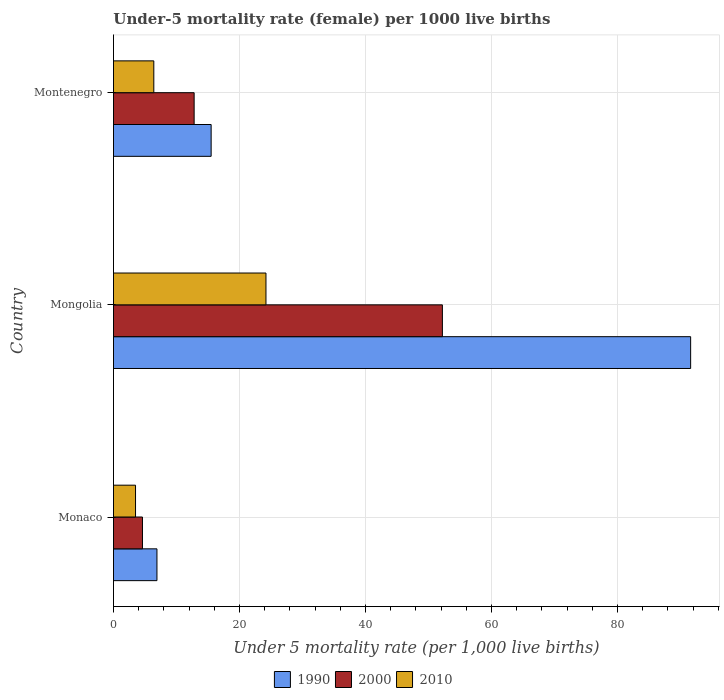How many groups of bars are there?
Provide a succinct answer. 3. What is the label of the 2nd group of bars from the top?
Provide a succinct answer. Mongolia. Across all countries, what is the maximum under-five mortality rate in 2010?
Your answer should be compact. 24.2. Across all countries, what is the minimum under-five mortality rate in 1990?
Your response must be concise. 6.9. In which country was the under-five mortality rate in 2010 maximum?
Provide a succinct answer. Mongolia. In which country was the under-five mortality rate in 1990 minimum?
Give a very brief answer. Monaco. What is the total under-five mortality rate in 2010 in the graph?
Make the answer very short. 34.1. What is the difference between the under-five mortality rate in 2000 in Monaco and that in Montenegro?
Give a very brief answer. -8.2. What is the difference between the under-five mortality rate in 2000 in Mongolia and the under-five mortality rate in 2010 in Montenegro?
Give a very brief answer. 45.8. What is the average under-five mortality rate in 1990 per country?
Offer a very short reply. 38. What is the difference between the under-five mortality rate in 1990 and under-five mortality rate in 2000 in Montenegro?
Keep it short and to the point. 2.7. In how many countries, is the under-five mortality rate in 2000 greater than 72 ?
Give a very brief answer. 0. What is the ratio of the under-five mortality rate in 2000 in Mongolia to that in Montenegro?
Your response must be concise. 4.08. Is the under-five mortality rate in 2000 in Monaco less than that in Mongolia?
Offer a terse response. Yes. What is the difference between the highest and the second highest under-five mortality rate in 2000?
Give a very brief answer. 39.4. What is the difference between the highest and the lowest under-five mortality rate in 2000?
Offer a terse response. 47.6. Is the sum of the under-five mortality rate in 2010 in Monaco and Montenegro greater than the maximum under-five mortality rate in 2000 across all countries?
Offer a very short reply. No. What does the 1st bar from the top in Monaco represents?
Your response must be concise. 2010. What does the 3rd bar from the bottom in Mongolia represents?
Your answer should be very brief. 2010. Is it the case that in every country, the sum of the under-five mortality rate in 2000 and under-five mortality rate in 2010 is greater than the under-five mortality rate in 1990?
Ensure brevity in your answer.  No. How many countries are there in the graph?
Your answer should be very brief. 3. Are the values on the major ticks of X-axis written in scientific E-notation?
Offer a terse response. No. Does the graph contain any zero values?
Offer a very short reply. No. Where does the legend appear in the graph?
Your response must be concise. Bottom center. What is the title of the graph?
Ensure brevity in your answer.  Under-5 mortality rate (female) per 1000 live births. Does "1988" appear as one of the legend labels in the graph?
Give a very brief answer. No. What is the label or title of the X-axis?
Offer a very short reply. Under 5 mortality rate (per 1,0 live births). What is the Under 5 mortality rate (per 1,000 live births) in 1990 in Monaco?
Your answer should be very brief. 6.9. What is the Under 5 mortality rate (per 1,000 live births) in 2000 in Monaco?
Your answer should be very brief. 4.6. What is the Under 5 mortality rate (per 1,000 live births) of 1990 in Mongolia?
Your answer should be compact. 91.6. What is the Under 5 mortality rate (per 1,000 live births) in 2000 in Mongolia?
Your answer should be compact. 52.2. What is the Under 5 mortality rate (per 1,000 live births) of 2010 in Mongolia?
Give a very brief answer. 24.2. What is the Under 5 mortality rate (per 1,000 live births) in 2010 in Montenegro?
Offer a terse response. 6.4. Across all countries, what is the maximum Under 5 mortality rate (per 1,000 live births) in 1990?
Provide a succinct answer. 91.6. Across all countries, what is the maximum Under 5 mortality rate (per 1,000 live births) in 2000?
Give a very brief answer. 52.2. Across all countries, what is the maximum Under 5 mortality rate (per 1,000 live births) in 2010?
Your answer should be very brief. 24.2. Across all countries, what is the minimum Under 5 mortality rate (per 1,000 live births) of 2010?
Offer a very short reply. 3.5. What is the total Under 5 mortality rate (per 1,000 live births) in 1990 in the graph?
Provide a short and direct response. 114. What is the total Under 5 mortality rate (per 1,000 live births) of 2000 in the graph?
Provide a succinct answer. 69.6. What is the total Under 5 mortality rate (per 1,000 live births) in 2010 in the graph?
Make the answer very short. 34.1. What is the difference between the Under 5 mortality rate (per 1,000 live births) of 1990 in Monaco and that in Mongolia?
Offer a terse response. -84.7. What is the difference between the Under 5 mortality rate (per 1,000 live births) of 2000 in Monaco and that in Mongolia?
Your answer should be compact. -47.6. What is the difference between the Under 5 mortality rate (per 1,000 live births) in 2010 in Monaco and that in Mongolia?
Provide a succinct answer. -20.7. What is the difference between the Under 5 mortality rate (per 1,000 live births) in 1990 in Monaco and that in Montenegro?
Ensure brevity in your answer.  -8.6. What is the difference between the Under 5 mortality rate (per 1,000 live births) in 1990 in Mongolia and that in Montenegro?
Your answer should be compact. 76.1. What is the difference between the Under 5 mortality rate (per 1,000 live births) in 2000 in Mongolia and that in Montenegro?
Give a very brief answer. 39.4. What is the difference between the Under 5 mortality rate (per 1,000 live births) of 2010 in Mongolia and that in Montenegro?
Make the answer very short. 17.8. What is the difference between the Under 5 mortality rate (per 1,000 live births) in 1990 in Monaco and the Under 5 mortality rate (per 1,000 live births) in 2000 in Mongolia?
Provide a short and direct response. -45.3. What is the difference between the Under 5 mortality rate (per 1,000 live births) of 1990 in Monaco and the Under 5 mortality rate (per 1,000 live births) of 2010 in Mongolia?
Offer a very short reply. -17.3. What is the difference between the Under 5 mortality rate (per 1,000 live births) in 2000 in Monaco and the Under 5 mortality rate (per 1,000 live births) in 2010 in Mongolia?
Your answer should be very brief. -19.6. What is the difference between the Under 5 mortality rate (per 1,000 live births) of 1990 in Monaco and the Under 5 mortality rate (per 1,000 live births) of 2000 in Montenegro?
Provide a succinct answer. -5.9. What is the difference between the Under 5 mortality rate (per 1,000 live births) of 1990 in Monaco and the Under 5 mortality rate (per 1,000 live births) of 2010 in Montenegro?
Offer a very short reply. 0.5. What is the difference between the Under 5 mortality rate (per 1,000 live births) in 2000 in Monaco and the Under 5 mortality rate (per 1,000 live births) in 2010 in Montenegro?
Offer a terse response. -1.8. What is the difference between the Under 5 mortality rate (per 1,000 live births) in 1990 in Mongolia and the Under 5 mortality rate (per 1,000 live births) in 2000 in Montenegro?
Your response must be concise. 78.8. What is the difference between the Under 5 mortality rate (per 1,000 live births) in 1990 in Mongolia and the Under 5 mortality rate (per 1,000 live births) in 2010 in Montenegro?
Your response must be concise. 85.2. What is the difference between the Under 5 mortality rate (per 1,000 live births) of 2000 in Mongolia and the Under 5 mortality rate (per 1,000 live births) of 2010 in Montenegro?
Provide a succinct answer. 45.8. What is the average Under 5 mortality rate (per 1,000 live births) of 2000 per country?
Provide a succinct answer. 23.2. What is the average Under 5 mortality rate (per 1,000 live births) in 2010 per country?
Ensure brevity in your answer.  11.37. What is the difference between the Under 5 mortality rate (per 1,000 live births) of 1990 and Under 5 mortality rate (per 1,000 live births) of 2000 in Monaco?
Your answer should be compact. 2.3. What is the difference between the Under 5 mortality rate (per 1,000 live births) in 2000 and Under 5 mortality rate (per 1,000 live births) in 2010 in Monaco?
Your answer should be very brief. 1.1. What is the difference between the Under 5 mortality rate (per 1,000 live births) of 1990 and Under 5 mortality rate (per 1,000 live births) of 2000 in Mongolia?
Offer a very short reply. 39.4. What is the difference between the Under 5 mortality rate (per 1,000 live births) of 1990 and Under 5 mortality rate (per 1,000 live births) of 2010 in Mongolia?
Provide a short and direct response. 67.4. What is the difference between the Under 5 mortality rate (per 1,000 live births) in 1990 and Under 5 mortality rate (per 1,000 live births) in 2000 in Montenegro?
Keep it short and to the point. 2.7. What is the difference between the Under 5 mortality rate (per 1,000 live births) of 1990 and Under 5 mortality rate (per 1,000 live births) of 2010 in Montenegro?
Your response must be concise. 9.1. What is the difference between the Under 5 mortality rate (per 1,000 live births) in 2000 and Under 5 mortality rate (per 1,000 live births) in 2010 in Montenegro?
Your response must be concise. 6.4. What is the ratio of the Under 5 mortality rate (per 1,000 live births) in 1990 in Monaco to that in Mongolia?
Offer a very short reply. 0.08. What is the ratio of the Under 5 mortality rate (per 1,000 live births) in 2000 in Monaco to that in Mongolia?
Your answer should be compact. 0.09. What is the ratio of the Under 5 mortality rate (per 1,000 live births) of 2010 in Monaco to that in Mongolia?
Make the answer very short. 0.14. What is the ratio of the Under 5 mortality rate (per 1,000 live births) in 1990 in Monaco to that in Montenegro?
Offer a very short reply. 0.45. What is the ratio of the Under 5 mortality rate (per 1,000 live births) of 2000 in Monaco to that in Montenegro?
Your answer should be very brief. 0.36. What is the ratio of the Under 5 mortality rate (per 1,000 live births) in 2010 in Monaco to that in Montenegro?
Provide a short and direct response. 0.55. What is the ratio of the Under 5 mortality rate (per 1,000 live births) in 1990 in Mongolia to that in Montenegro?
Keep it short and to the point. 5.91. What is the ratio of the Under 5 mortality rate (per 1,000 live births) of 2000 in Mongolia to that in Montenegro?
Your response must be concise. 4.08. What is the ratio of the Under 5 mortality rate (per 1,000 live births) of 2010 in Mongolia to that in Montenegro?
Offer a terse response. 3.78. What is the difference between the highest and the second highest Under 5 mortality rate (per 1,000 live births) in 1990?
Offer a very short reply. 76.1. What is the difference between the highest and the second highest Under 5 mortality rate (per 1,000 live births) of 2000?
Ensure brevity in your answer.  39.4. What is the difference between the highest and the lowest Under 5 mortality rate (per 1,000 live births) in 1990?
Provide a short and direct response. 84.7. What is the difference between the highest and the lowest Under 5 mortality rate (per 1,000 live births) of 2000?
Keep it short and to the point. 47.6. What is the difference between the highest and the lowest Under 5 mortality rate (per 1,000 live births) of 2010?
Provide a succinct answer. 20.7. 